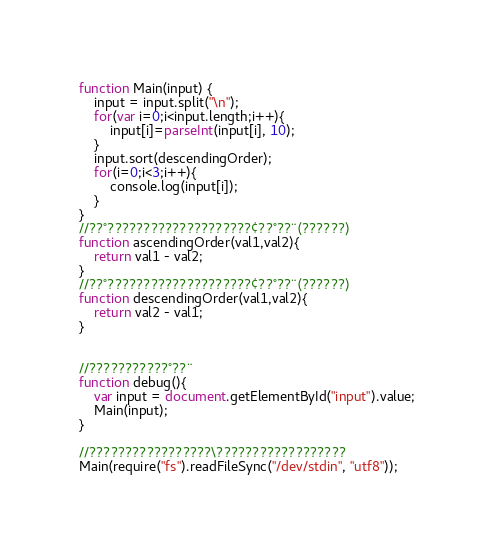Convert code to text. <code><loc_0><loc_0><loc_500><loc_500><_JavaScript_>function Main(input) {
    input = input.split("\n");
    for(var i=0;i<input.length;i++){
        input[i]=parseInt(input[i], 10);
    }
    input.sort(descendingOrder);
    for(i=0;i<3;i++){
        console.log(input[i]);
    }
}
//??°????????????????????¢??°??¨(??????)
function ascendingOrder(val1,val2){
    return val1 - val2;
}
//??°????????????????????¢??°??¨(??????)
function descendingOrder(val1,val2){
    return val2 - val1;
}


//???????????°??¨
function debug(){
	var input = document.getElementById("input").value;
	Main(input);
}

//?????????????????\??????????????????
Main(require("fs").readFileSync("/dev/stdin", "utf8"));</code> 